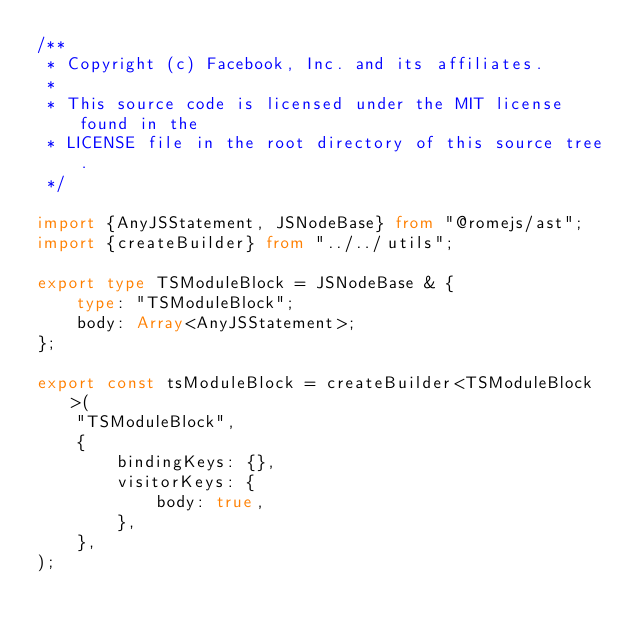Convert code to text. <code><loc_0><loc_0><loc_500><loc_500><_TypeScript_>/**
 * Copyright (c) Facebook, Inc. and its affiliates.
 *
 * This source code is licensed under the MIT license found in the
 * LICENSE file in the root directory of this source tree.
 */

import {AnyJSStatement, JSNodeBase} from "@romejs/ast";
import {createBuilder} from "../../utils";

export type TSModuleBlock = JSNodeBase & {
	type: "TSModuleBlock";
	body: Array<AnyJSStatement>;
};

export const tsModuleBlock = createBuilder<TSModuleBlock>(
	"TSModuleBlock",
	{
		bindingKeys: {},
		visitorKeys: {
			body: true,
		},
	},
);
</code> 